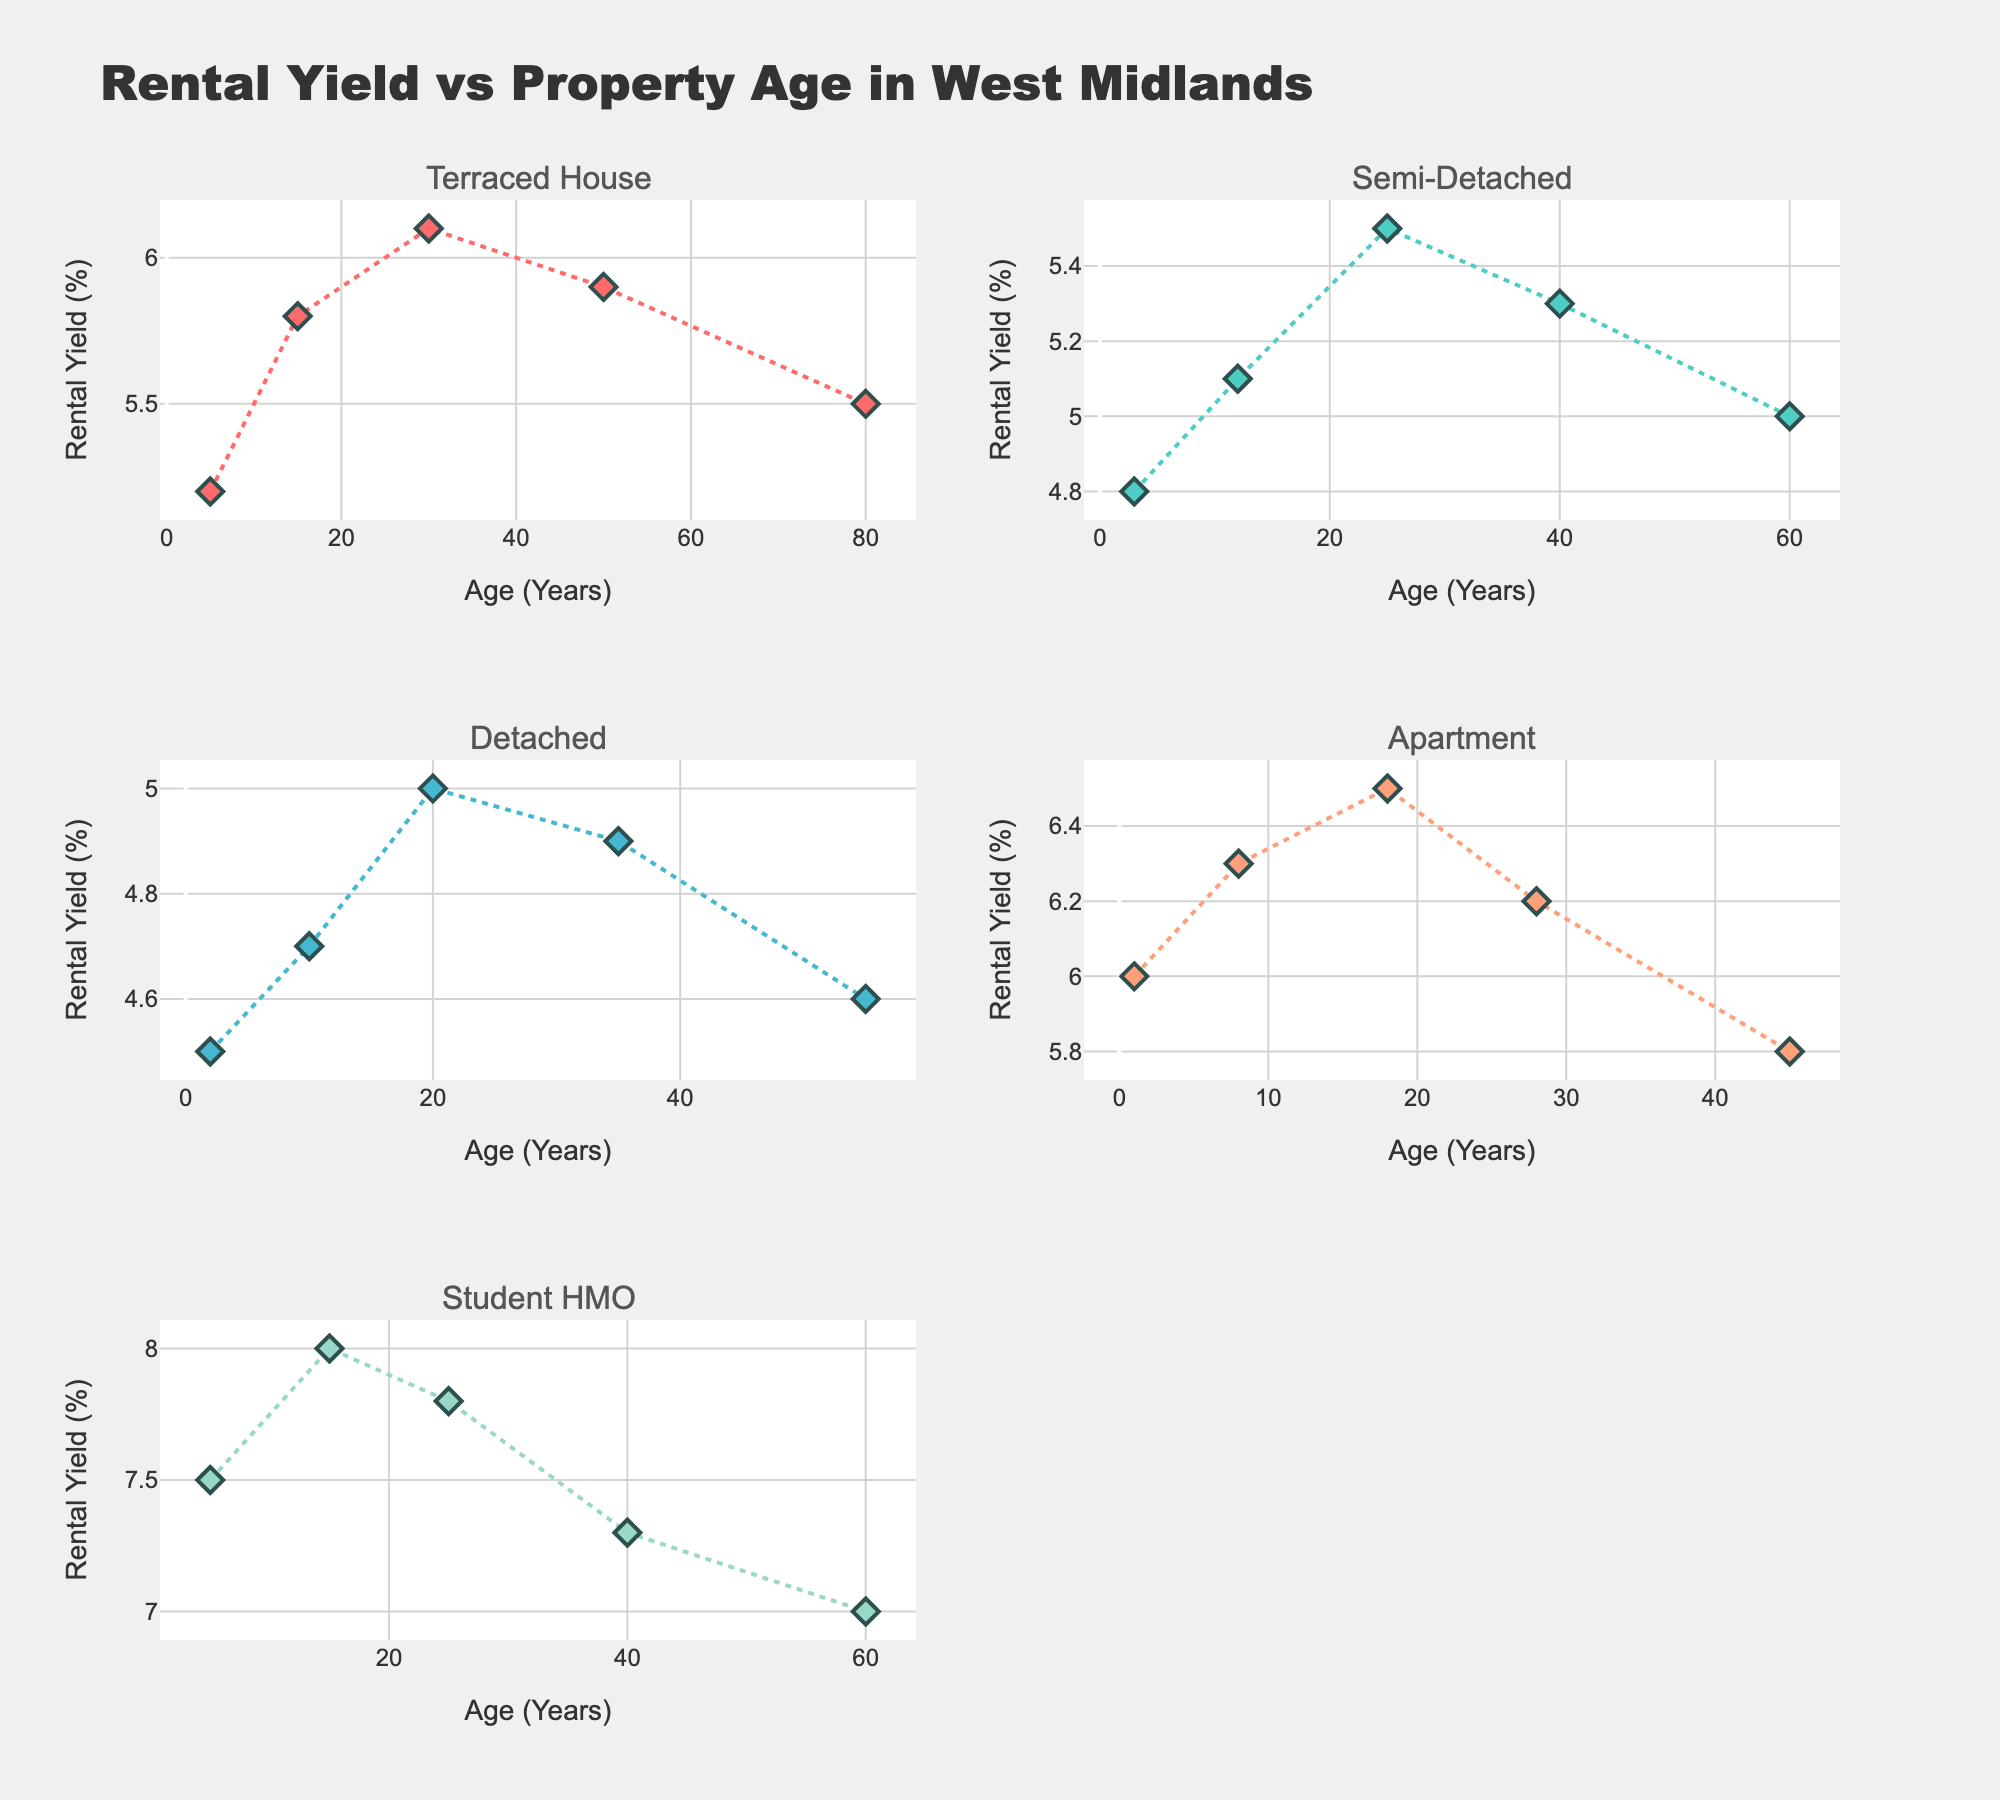What is the title of the figure? The title is usually prominently displayed at the top of the figure, describing the content or purpose of the data visualization. Here, the title reads "Rental Yield vs Property Age in West Midlands".
Answer: Rental Yield vs Property Age in West Midlands How many subplots are there in the figure? The figure uses a 3x2 grid to display subplots, which translates to 6 subplots in total. Each subplot represents a different property type.
Answer: 6 Which property type shows the highest rental yield? By looking at the individual subplots, we can observe the peak points of each plot. The Student HMO subplot shows the highest peak rental yield among all property types.
Answer: Student HMO What colors are used to represent the different property types? Each property type is represented by a unique color. These colors are soft tones distinctively used in the subplots: Terraced House in red, Semi-Detached in light teal, Detached in light blue, Apartment in salmon, and Student HMO in mint green.
Answer: Red, light teal, light blue, salmon, mint green For which property type does rental yield decrease as the property age increases? By examining the trend in each subplot, the Apartment and Student HMO types show a noticeable downward trend in rental yield as property age increases.
Answer: Apartment, Student HMO Which property type shows the most consistent rental yields irrespective of age? By looking at the plots, Semi-Detached shows fairly consistent rental yields with smaller fluctuations across different property ages.
Answer: Semi-Detached How does the rental yield at age 20 compare between Detached houses and Apartments? By comparing the data points for the age of 20 in both Detached houses and Apartments subplots, it is clear that Apartments have a higher rental yield at this age. Detached houses have around 5.0%, while Apartments have around 6.5%.
Answer: Apartments have a higher rental yield What is the average rental yield for Detached houses? To compute the average, sum up the rental yields for Detached houses and divide by the number of data points: (4.5 + 4.7 + 5.0 + 4.9 + 4.6) / 5 = 23.7 / 5 = 4.74%.
Answer: 4.74% Which property type has the greatest variability in rental yields? Variability can be observed by noticing how spread out the data points are. Student HMO shows the greatest variability with rental yields ranging from 7% to 8%.
Answer: Student HMO What is the trend for rental yield in Terraced houses as the age of the property increases? Observing the subplot for Terraced Houses, the rental yield increases up to 30 years and then slightly decreases again as the property ages further.
Answer: Increases then decreases 